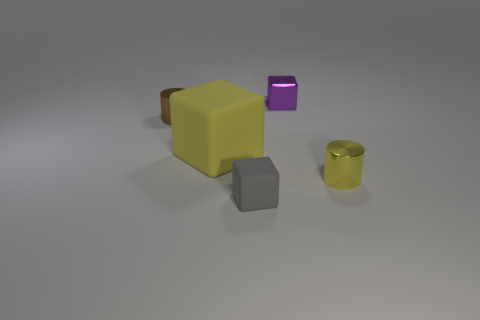What might be the purpose of the shiny cylinder? The shiny cylinder, with its metallic golden finish, looks like it could be a container or a decorative piece. Its reflective surface gives it an air of luxury, and if it were functional, it might be used to hold small items or as a simple vase. However, without additional context, its specific purpose remains open to interpretation. 